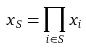<formula> <loc_0><loc_0><loc_500><loc_500>x _ { S } = \prod _ { i \in S } x _ { i }</formula> 